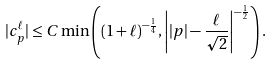Convert formula to latex. <formula><loc_0><loc_0><loc_500><loc_500>| c _ { p } ^ { \ell } | \leq C \min \left ( ( 1 + \ell ) ^ { - \frac { 1 } { 4 } } , \left | | p | - \frac { \ell } { \sqrt { 2 } } \right | ^ { - \frac { 1 } { 2 } } \right ) .</formula> 